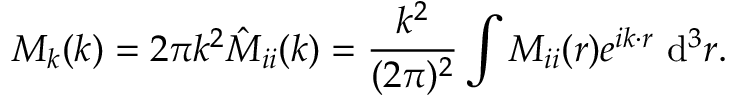Convert formula to latex. <formula><loc_0><loc_0><loc_500><loc_500>M _ { k } ( k ) = 2 \pi k ^ { 2 } \hat { M } _ { i i } ( k ) = \frac { k ^ { 2 } } { ( 2 \pi ) ^ { 2 } } \int M _ { i i } ( r ) e ^ { i k \cdot r } d ^ { 3 } r .</formula> 